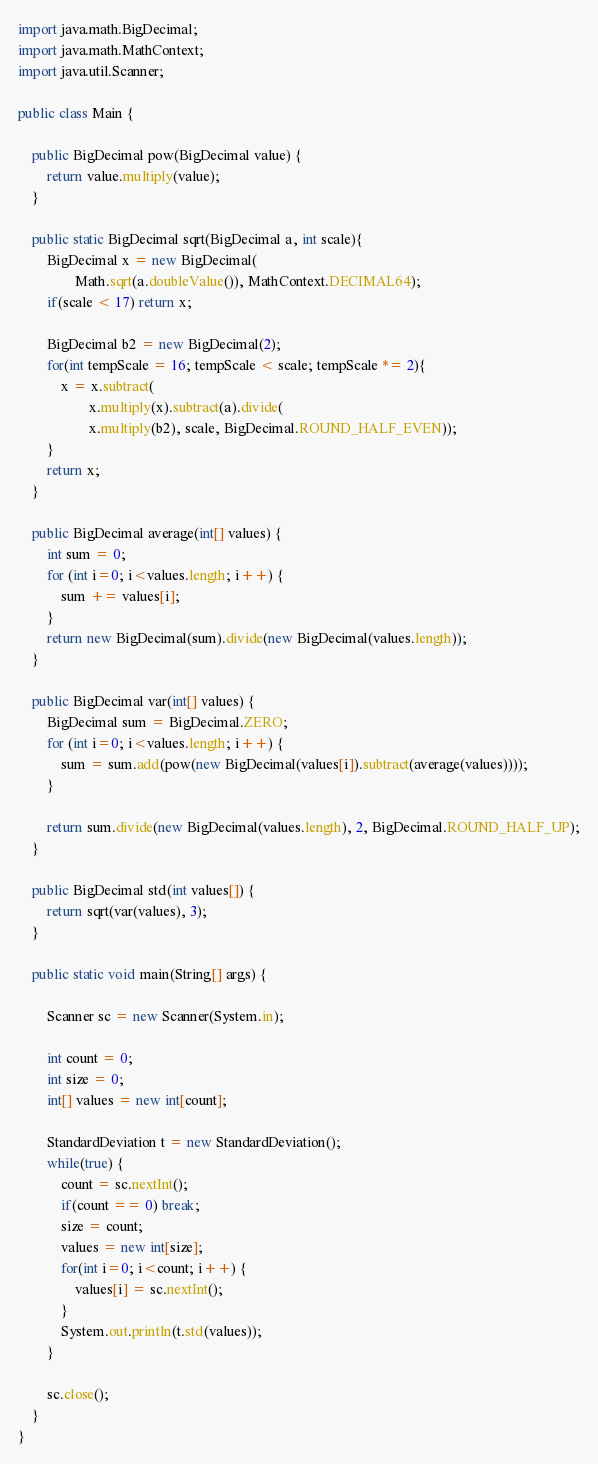<code> <loc_0><loc_0><loc_500><loc_500><_Java_>import java.math.BigDecimal;
import java.math.MathContext;
import java.util.Scanner;

public class Main {

    public BigDecimal pow(BigDecimal value) {
        return value.multiply(value);
    }

    public static BigDecimal sqrt(BigDecimal a, int scale){
        BigDecimal x = new BigDecimal(
                Math.sqrt(a.doubleValue()), MathContext.DECIMAL64);
        if(scale < 17) return x;

        BigDecimal b2 = new BigDecimal(2);
        for(int tempScale = 16; tempScale < scale; tempScale *= 2){
            x = x.subtract(
                    x.multiply(x).subtract(a).divide(
                    x.multiply(b2), scale, BigDecimal.ROUND_HALF_EVEN));
        }
        return x;
    }

    public BigDecimal average(int[] values) {
        int sum = 0;
        for (int i=0; i<values.length; i++) {
            sum += values[i];
        }
        return new BigDecimal(sum).divide(new BigDecimal(values.length));
    }

    public BigDecimal var(int[] values) {
        BigDecimal sum = BigDecimal.ZERO;
        for (int i=0; i<values.length; i++) {
            sum = sum.add(pow(new BigDecimal(values[i]).subtract(average(values))));
        }

        return sum.divide(new BigDecimal(values.length), 2, BigDecimal.ROUND_HALF_UP);
    }

    public BigDecimal std(int values[]) {
        return sqrt(var(values), 3);
    }

    public static void main(String[] args) {

    	Scanner sc = new Scanner(System.in);

        int count = 0;
        int size = 0;
        int[] values = new int[count];

        StandardDeviation t = new StandardDeviation();
        while(true) {
        	count = sc.nextInt();
        	if(count == 0) break;
            size = count;
            values = new int[size];
        	for(int i=0; i<count; i++) {
        		values[i] = sc.nextInt();
        	}
        	System.out.println(t.std(values));
        }

        sc.close();
    }
}
</code> 